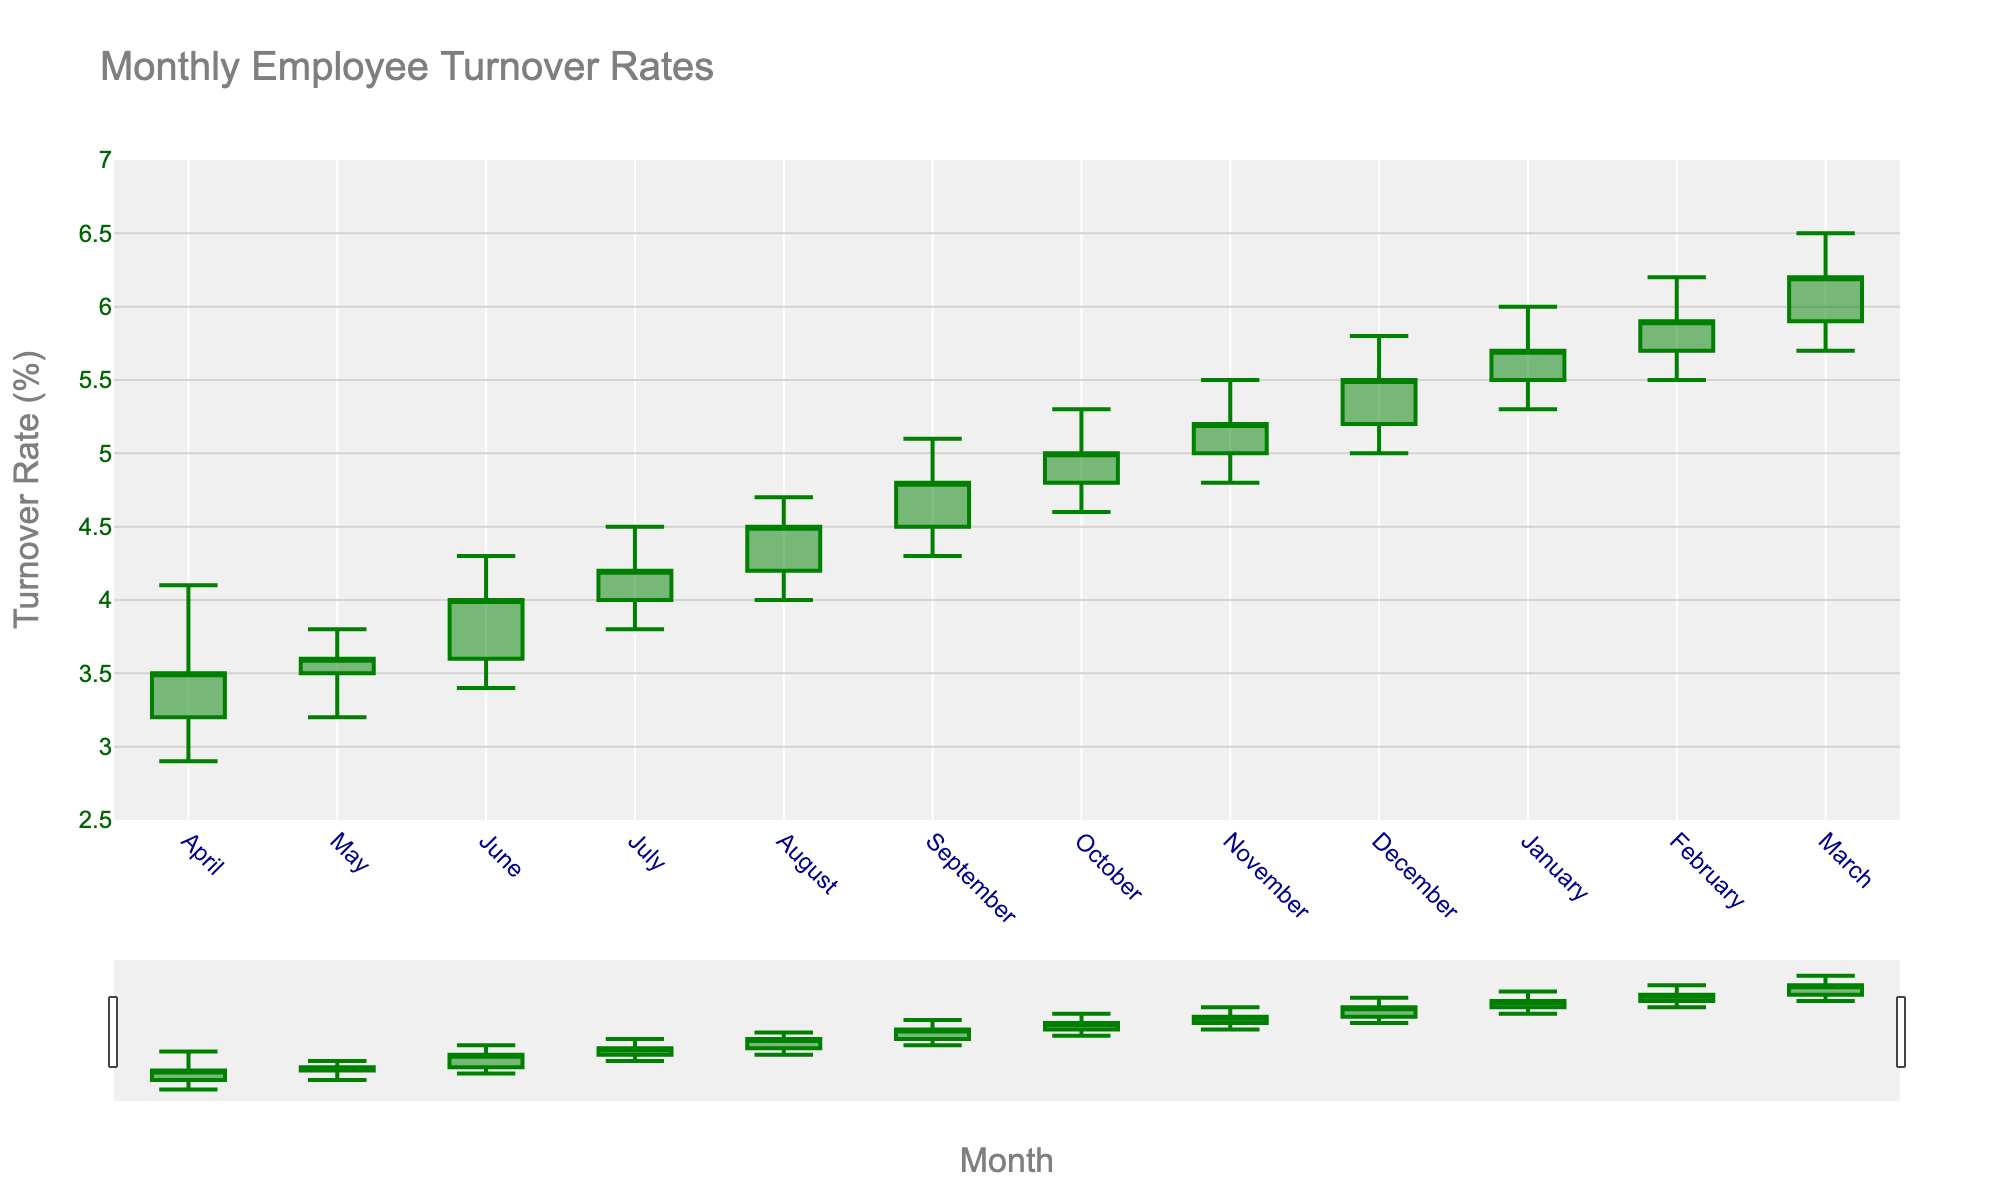What's the title of the figure? The title of a figure is typically located at the top of the chart and is used to describe the content of the chart. In this case, it is "Monthly Employee Turnover Rates" as specified in the code.
Answer: Monthly Employee Turnover Rates What color are the increasing bars in the chart? The chart uses candlesticks to represent data, with increasing values shown in green, as specified in the code.
Answer: Green In which month did the lowest turnover rate occur, and what was it? To find the lowest turnover rate, we look at the 'Low' values for each month. The lowest value is 2.9 in April.
Answer: April, 2.9% What is the month with the highest turnover rate, and what was the value? To find the month with the highest turnover rate, check the 'High' values. The highest value is 6.5 in March.
Answer: March, 6.5% How did the turnover rate change from January to February? Check the 'Close' rate for January and February. January's close is 5.7% and February's close is 5.9%. Subtract January's close from February's close to find the difference (5.9 - 5.7).
Answer: Increased by 0.2% Compare the turnover rates between June and July. Was there an increase or decrease in both the Open and Close rates? For June, the Open rate is 3.6% and Close rate is 4.0%. For July, the Open rate is 4.0% and Close rate is 4.2%. Both the Open and Close rates increased (4.0 - 3.6 and 4.2 - 4.0).
Answer: Increased for both Calculate the average of the 'Close' rates from April to March. Sum the 'Close' rates for all months from April to March (3.5 + 3.6 + 4.0 + 4.2 + 4.5 + 4.8 + 5.0 + 5.2 + 5.5 + 5.7 + 5.9 + 6.2) and divide by the number of months (12).
Answer: 4.75% Which month had the biggest spread between the high and low turnover rates? To find the month with the biggest spread, subtract the 'Low' from the 'High' for each month and find the maximum value. March has the biggest spread with a range of 0.8 (6.5 - 5.7).
Answer: March Describe the overall trend in the turnover rates over the year. Observing the 'Close' rates from April to March, there's a clear upward trend. The rates increase from 3.5% in April to 6.2% in March.
Answer: Increasing trend 